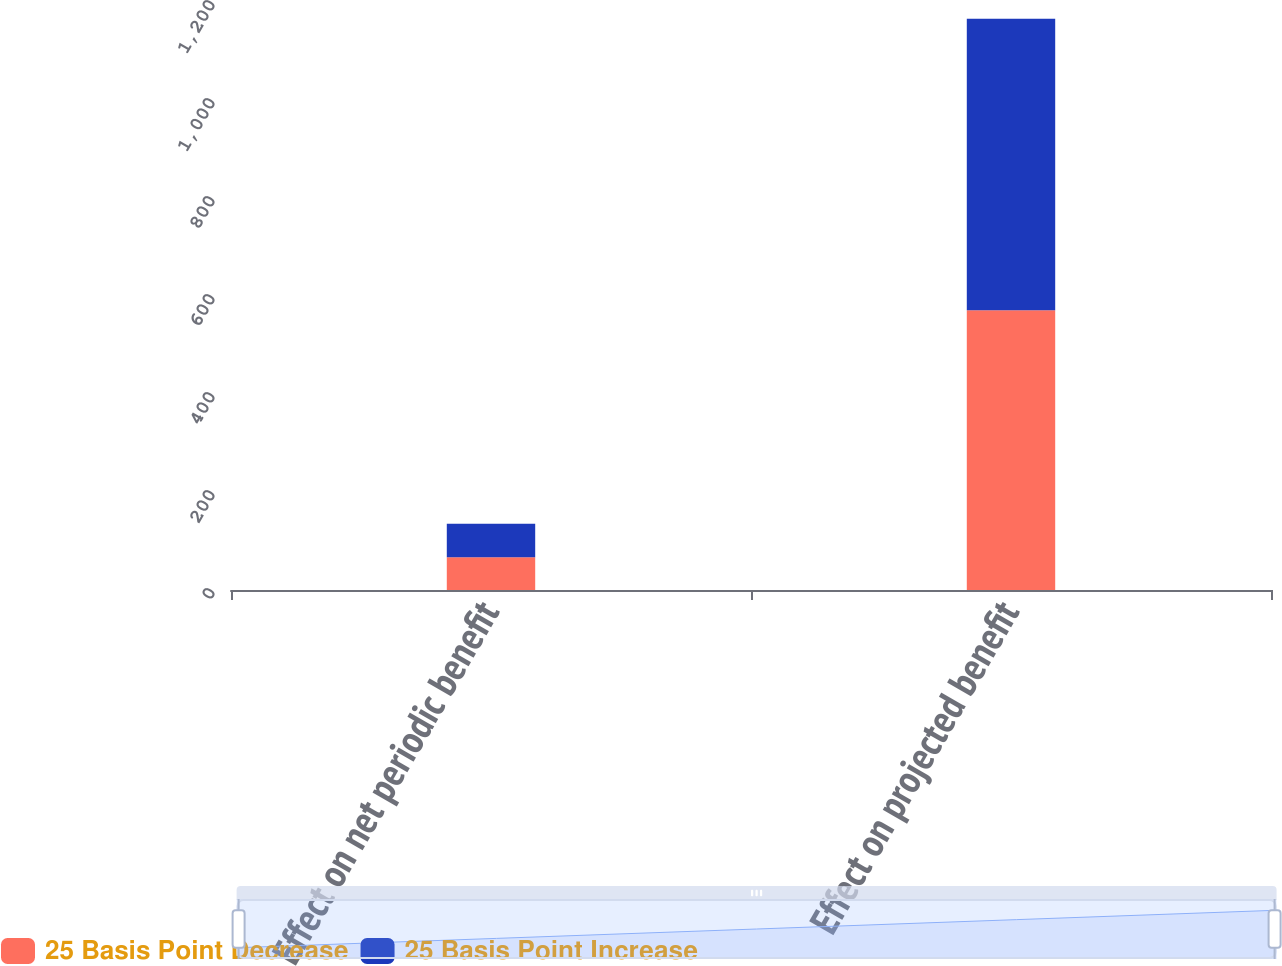Convert chart to OTSL. <chart><loc_0><loc_0><loc_500><loc_500><stacked_bar_chart><ecel><fcel>Effect on net periodic benefit<fcel>Effect on projected benefit<nl><fcel>25 Basis Point Decrease<fcel>67<fcel>571<nl><fcel>25 Basis Point Increase<fcel>68<fcel>595<nl></chart> 